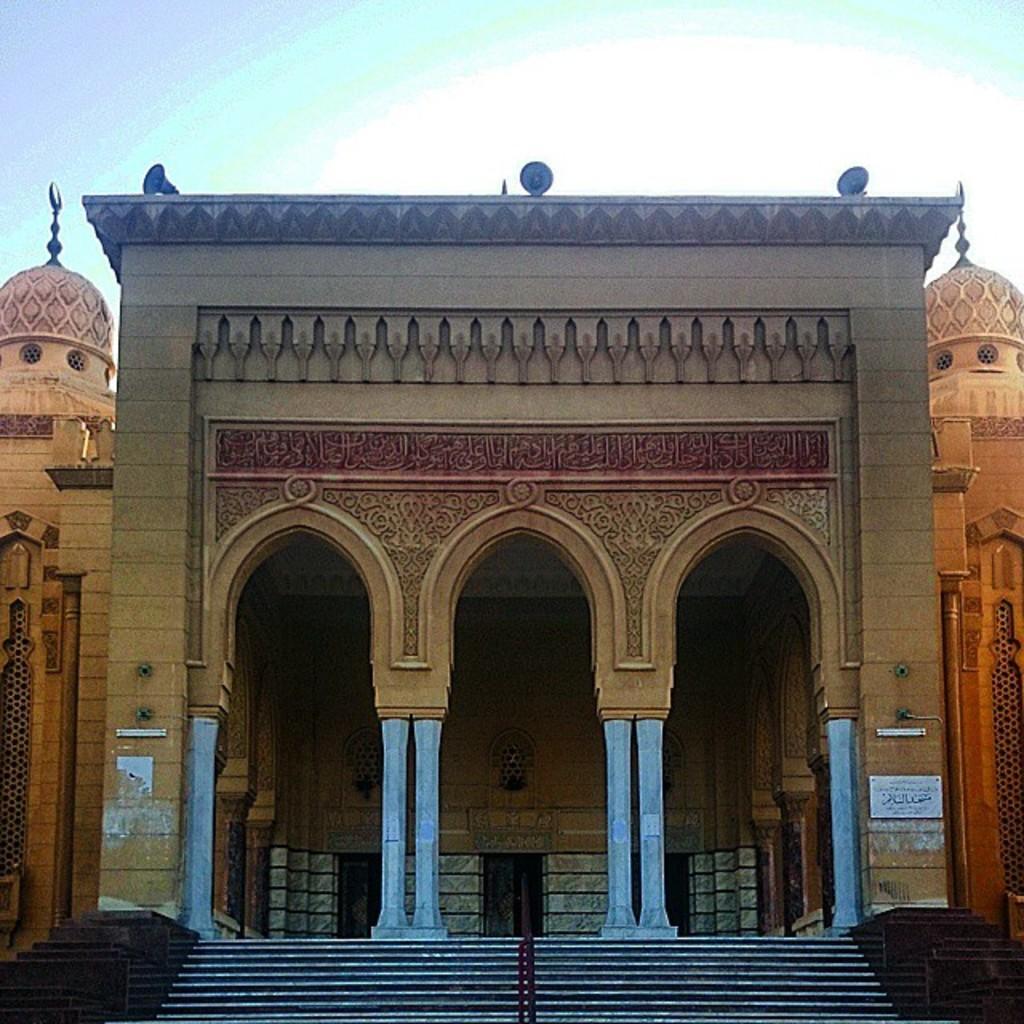Could you give a brief overview of what you see in this image? In this picture we can see buildings and some staircases. 